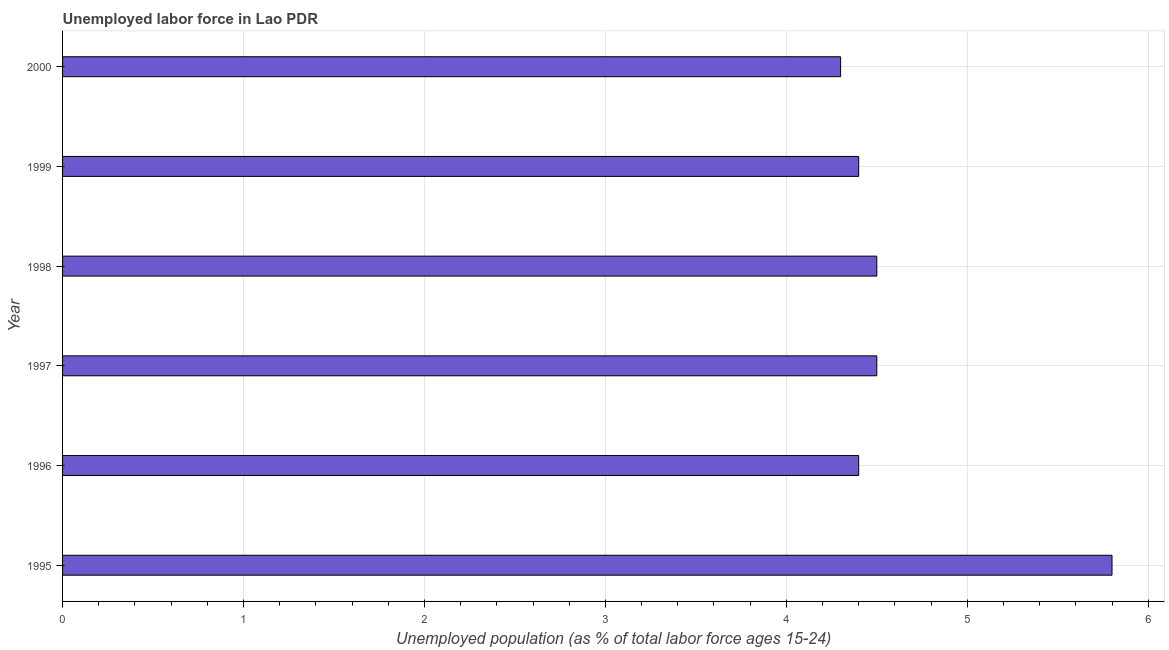What is the title of the graph?
Keep it short and to the point. Unemployed labor force in Lao PDR. What is the label or title of the X-axis?
Provide a succinct answer. Unemployed population (as % of total labor force ages 15-24). What is the label or title of the Y-axis?
Give a very brief answer. Year. What is the total unemployed youth population in 1998?
Provide a succinct answer. 4.5. Across all years, what is the maximum total unemployed youth population?
Ensure brevity in your answer.  5.8. Across all years, what is the minimum total unemployed youth population?
Your response must be concise. 4.3. In which year was the total unemployed youth population maximum?
Offer a terse response. 1995. What is the sum of the total unemployed youth population?
Give a very brief answer. 27.9. What is the difference between the total unemployed youth population in 1996 and 2000?
Make the answer very short. 0.1. What is the average total unemployed youth population per year?
Your answer should be compact. 4.65. What is the median total unemployed youth population?
Your answer should be very brief. 4.45. Do a majority of the years between 1998 and 1996 (inclusive) have total unemployed youth population greater than 2.2 %?
Your answer should be very brief. Yes. Is the total unemployed youth population in 1997 less than that in 1998?
Make the answer very short. No. How many years are there in the graph?
Provide a short and direct response. 6. What is the Unemployed population (as % of total labor force ages 15-24) of 1995?
Offer a very short reply. 5.8. What is the Unemployed population (as % of total labor force ages 15-24) in 1996?
Ensure brevity in your answer.  4.4. What is the Unemployed population (as % of total labor force ages 15-24) of 1998?
Make the answer very short. 4.5. What is the Unemployed population (as % of total labor force ages 15-24) in 1999?
Keep it short and to the point. 4.4. What is the Unemployed population (as % of total labor force ages 15-24) of 2000?
Ensure brevity in your answer.  4.3. What is the difference between the Unemployed population (as % of total labor force ages 15-24) in 1995 and 1996?
Make the answer very short. 1.4. What is the difference between the Unemployed population (as % of total labor force ages 15-24) in 1995 and 1997?
Offer a very short reply. 1.3. What is the difference between the Unemployed population (as % of total labor force ages 15-24) in 1995 and 1998?
Give a very brief answer. 1.3. What is the difference between the Unemployed population (as % of total labor force ages 15-24) in 1995 and 1999?
Ensure brevity in your answer.  1.4. What is the difference between the Unemployed population (as % of total labor force ages 15-24) in 1995 and 2000?
Ensure brevity in your answer.  1.5. What is the difference between the Unemployed population (as % of total labor force ages 15-24) in 1996 and 1997?
Offer a very short reply. -0.1. What is the difference between the Unemployed population (as % of total labor force ages 15-24) in 1996 and 1998?
Ensure brevity in your answer.  -0.1. What is the difference between the Unemployed population (as % of total labor force ages 15-24) in 1996 and 2000?
Your response must be concise. 0.1. What is the difference between the Unemployed population (as % of total labor force ages 15-24) in 1997 and 1998?
Make the answer very short. 0. What is the difference between the Unemployed population (as % of total labor force ages 15-24) in 1997 and 2000?
Your answer should be very brief. 0.2. What is the difference between the Unemployed population (as % of total labor force ages 15-24) in 1998 and 1999?
Provide a succinct answer. 0.1. What is the ratio of the Unemployed population (as % of total labor force ages 15-24) in 1995 to that in 1996?
Your answer should be very brief. 1.32. What is the ratio of the Unemployed population (as % of total labor force ages 15-24) in 1995 to that in 1997?
Ensure brevity in your answer.  1.29. What is the ratio of the Unemployed population (as % of total labor force ages 15-24) in 1995 to that in 1998?
Your answer should be compact. 1.29. What is the ratio of the Unemployed population (as % of total labor force ages 15-24) in 1995 to that in 1999?
Offer a very short reply. 1.32. What is the ratio of the Unemployed population (as % of total labor force ages 15-24) in 1995 to that in 2000?
Your answer should be very brief. 1.35. What is the ratio of the Unemployed population (as % of total labor force ages 15-24) in 1996 to that in 1997?
Offer a terse response. 0.98. What is the ratio of the Unemployed population (as % of total labor force ages 15-24) in 1996 to that in 1998?
Ensure brevity in your answer.  0.98. What is the ratio of the Unemployed population (as % of total labor force ages 15-24) in 1996 to that in 1999?
Provide a succinct answer. 1. What is the ratio of the Unemployed population (as % of total labor force ages 15-24) in 1996 to that in 2000?
Offer a terse response. 1.02. What is the ratio of the Unemployed population (as % of total labor force ages 15-24) in 1997 to that in 2000?
Your answer should be compact. 1.05. What is the ratio of the Unemployed population (as % of total labor force ages 15-24) in 1998 to that in 2000?
Make the answer very short. 1.05. What is the ratio of the Unemployed population (as % of total labor force ages 15-24) in 1999 to that in 2000?
Your answer should be very brief. 1.02. 